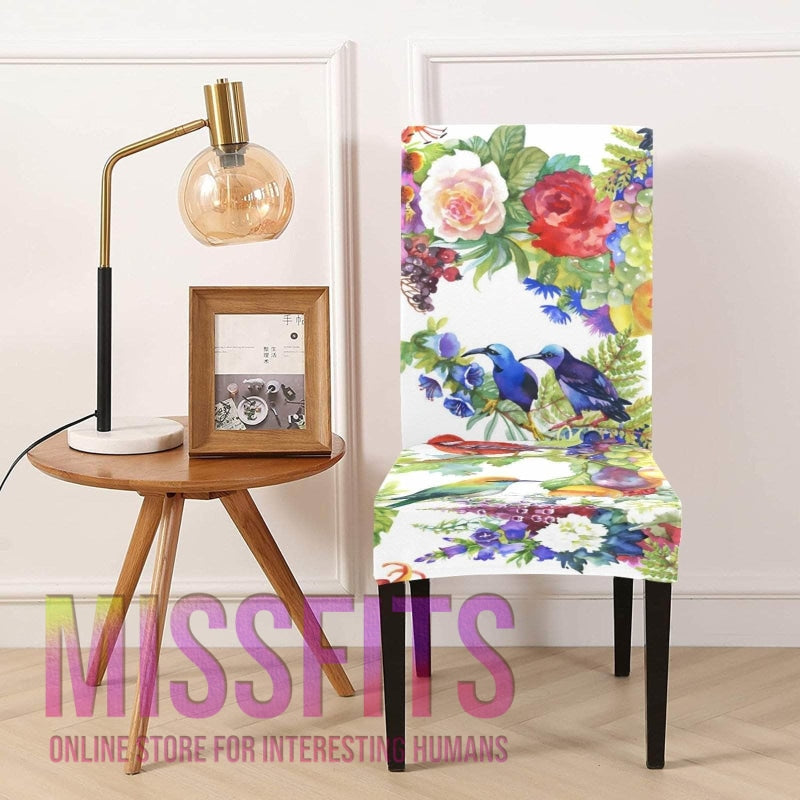What design style does the floral-patterned chair represent? The chair's design with its bright floral print and depiction of birds suggests a contemporary style with an appreciation for bold colors and nature-inspired themes. It bridges modern aesthetic sensibilities with classic motifs often found in traditional decor. 